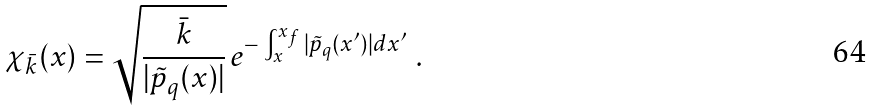Convert formula to latex. <formula><loc_0><loc_0><loc_500><loc_500>\chi _ { \bar { k } } ( x ) = \sqrt { \frac { \bar { k } } { | \tilde { p } _ { q } ( x ) | } } \, e ^ { - \, \int _ { x } ^ { x _ { f } } | \tilde { p } _ { q } ( x ^ { \prime } ) | d x ^ { \prime } } \ .</formula> 